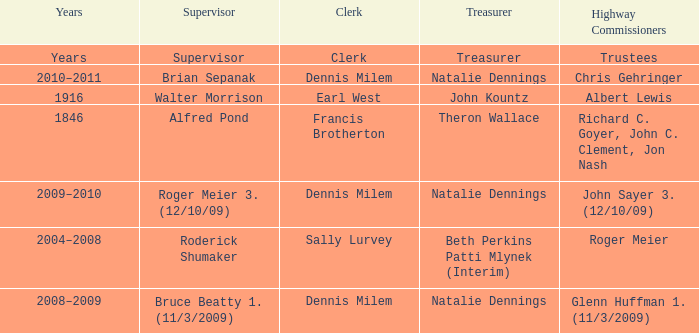When Treasurer was treasurer, who was the highway commissioner? Trustees. 